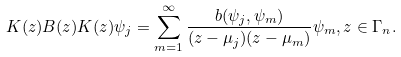Convert formula to latex. <formula><loc_0><loc_0><loc_500><loc_500>K ( z ) B ( z ) K ( z ) \psi _ { j } = \sum _ { m = 1 } ^ { \infty } \frac { b ( \psi _ { j } , \psi _ { m } ) } { ( z - \mu _ { j } ) ( z - \mu _ { m } ) } \psi _ { m } , z \in \Gamma _ { n } .</formula> 